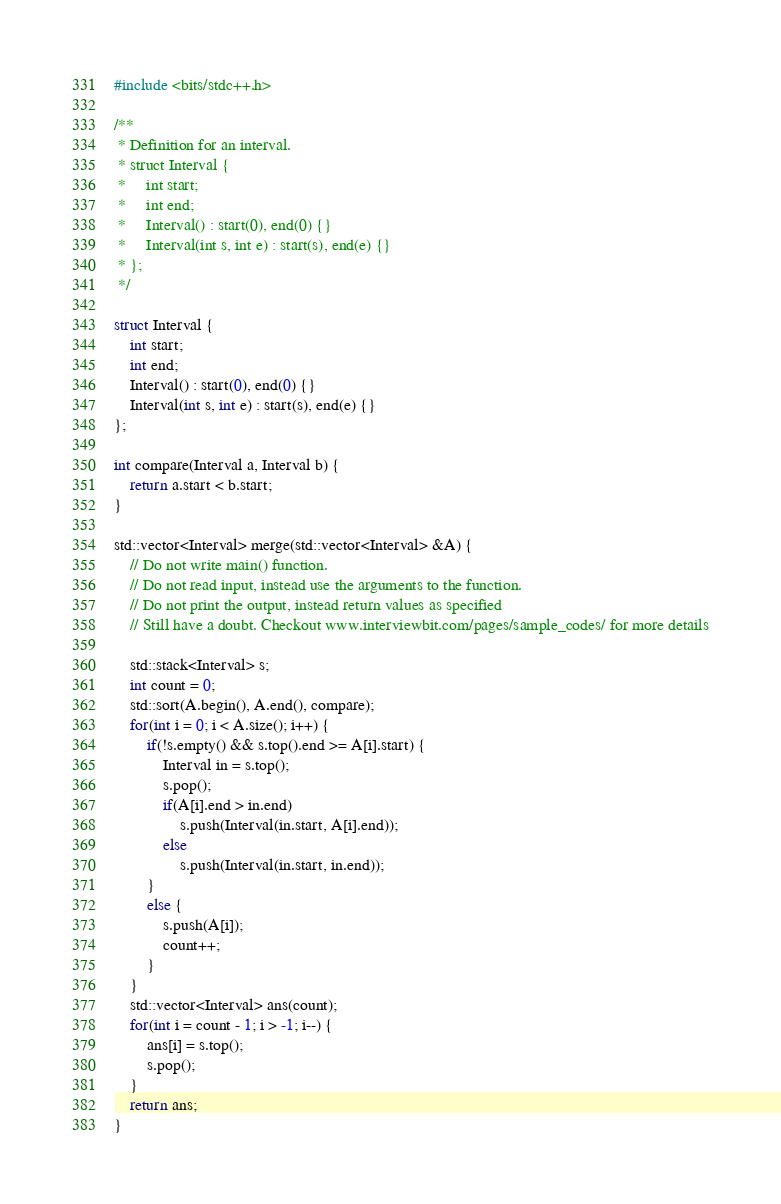<code> <loc_0><loc_0><loc_500><loc_500><_C++_>#include <bits/stdc++.h>

/**
 * Definition for an interval.
 * struct Interval {
 *     int start;
 *     int end;
 *     Interval() : start(0), end(0) {}
 *     Interval(int s, int e) : start(s), end(e) {}
 * };
 */

struct Interval {
    int start;
    int end;
    Interval() : start(0), end(0) {}
    Interval(int s, int e) : start(s), end(e) {}
};

int compare(Interval a, Interval b) {
    return a.start < b.start;
}

std::vector<Interval> merge(std::vector<Interval> &A) {
    // Do not write main() function.
    // Do not read input, instead use the arguments to the function.
    // Do not print the output, instead return values as specified
    // Still have a doubt. Checkout www.interviewbit.com/pages/sample_codes/ for more details

    std::stack<Interval> s;
    int count = 0;
    std::sort(A.begin(), A.end(), compare);
    for(int i = 0; i < A.size(); i++) {
        if(!s.empty() && s.top().end >= A[i].start) {
            Interval in = s.top();
            s.pop();
            if(A[i].end > in.end)
                s.push(Interval(in.start, A[i].end));
            else
                s.push(Interval(in.start, in.end));
        }
        else {
            s.push(A[i]);
            count++;
        }
    }
    std::vector<Interval> ans(count);
    for(int i = count - 1; i > -1; i--) {
        ans[i] = s.top();
        s.pop();
    }
    return ans;
}
</code> 